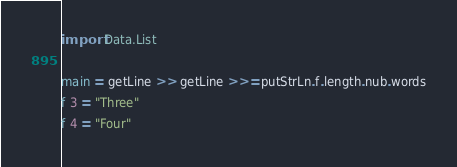<code> <loc_0><loc_0><loc_500><loc_500><_Haskell_>import Data.List

main = getLine >> getLine >>= putStrLn.f.length.nub.words
f 3 = "Three"
f 4 = "Four"</code> 